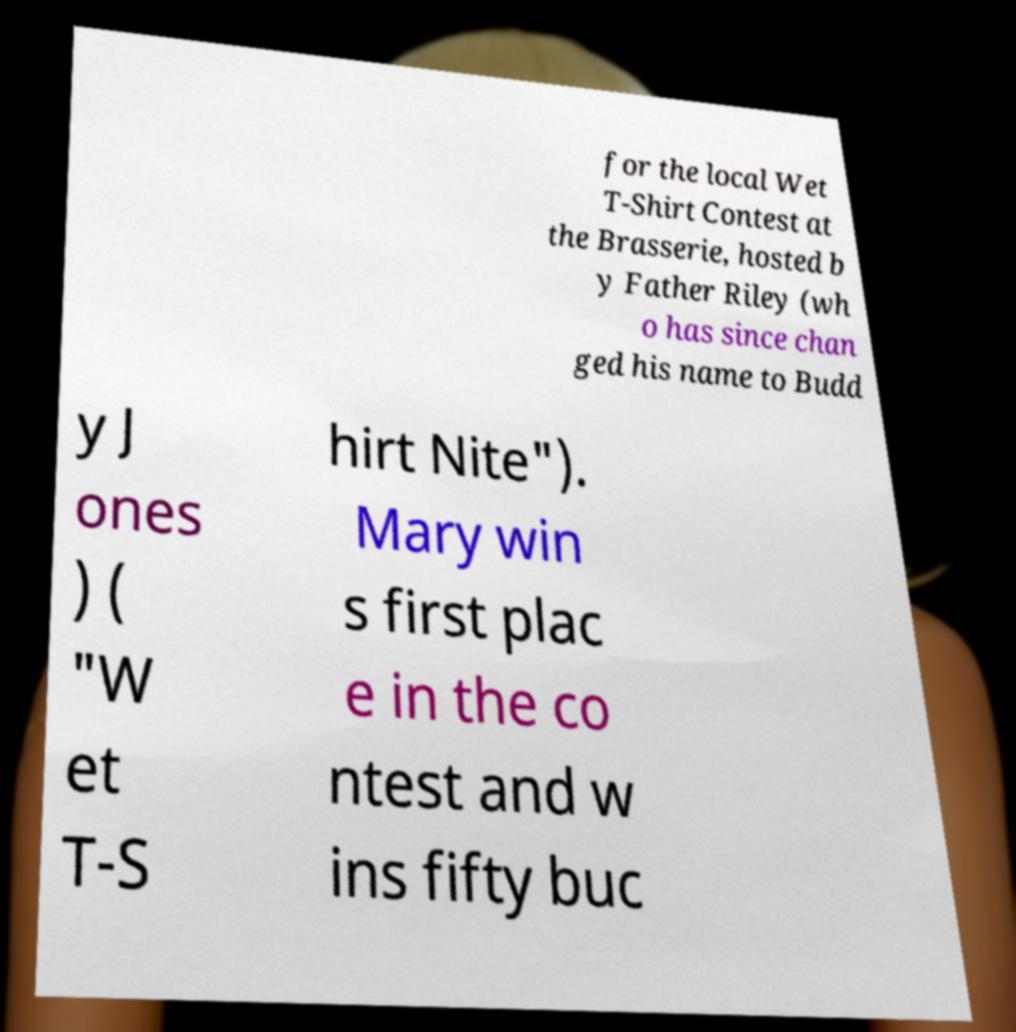Please identify and transcribe the text found in this image. for the local Wet T-Shirt Contest at the Brasserie, hosted b y Father Riley (wh o has since chan ged his name to Budd y J ones ) ( "W et T-S hirt Nite"). Mary win s first plac e in the co ntest and w ins fifty buc 